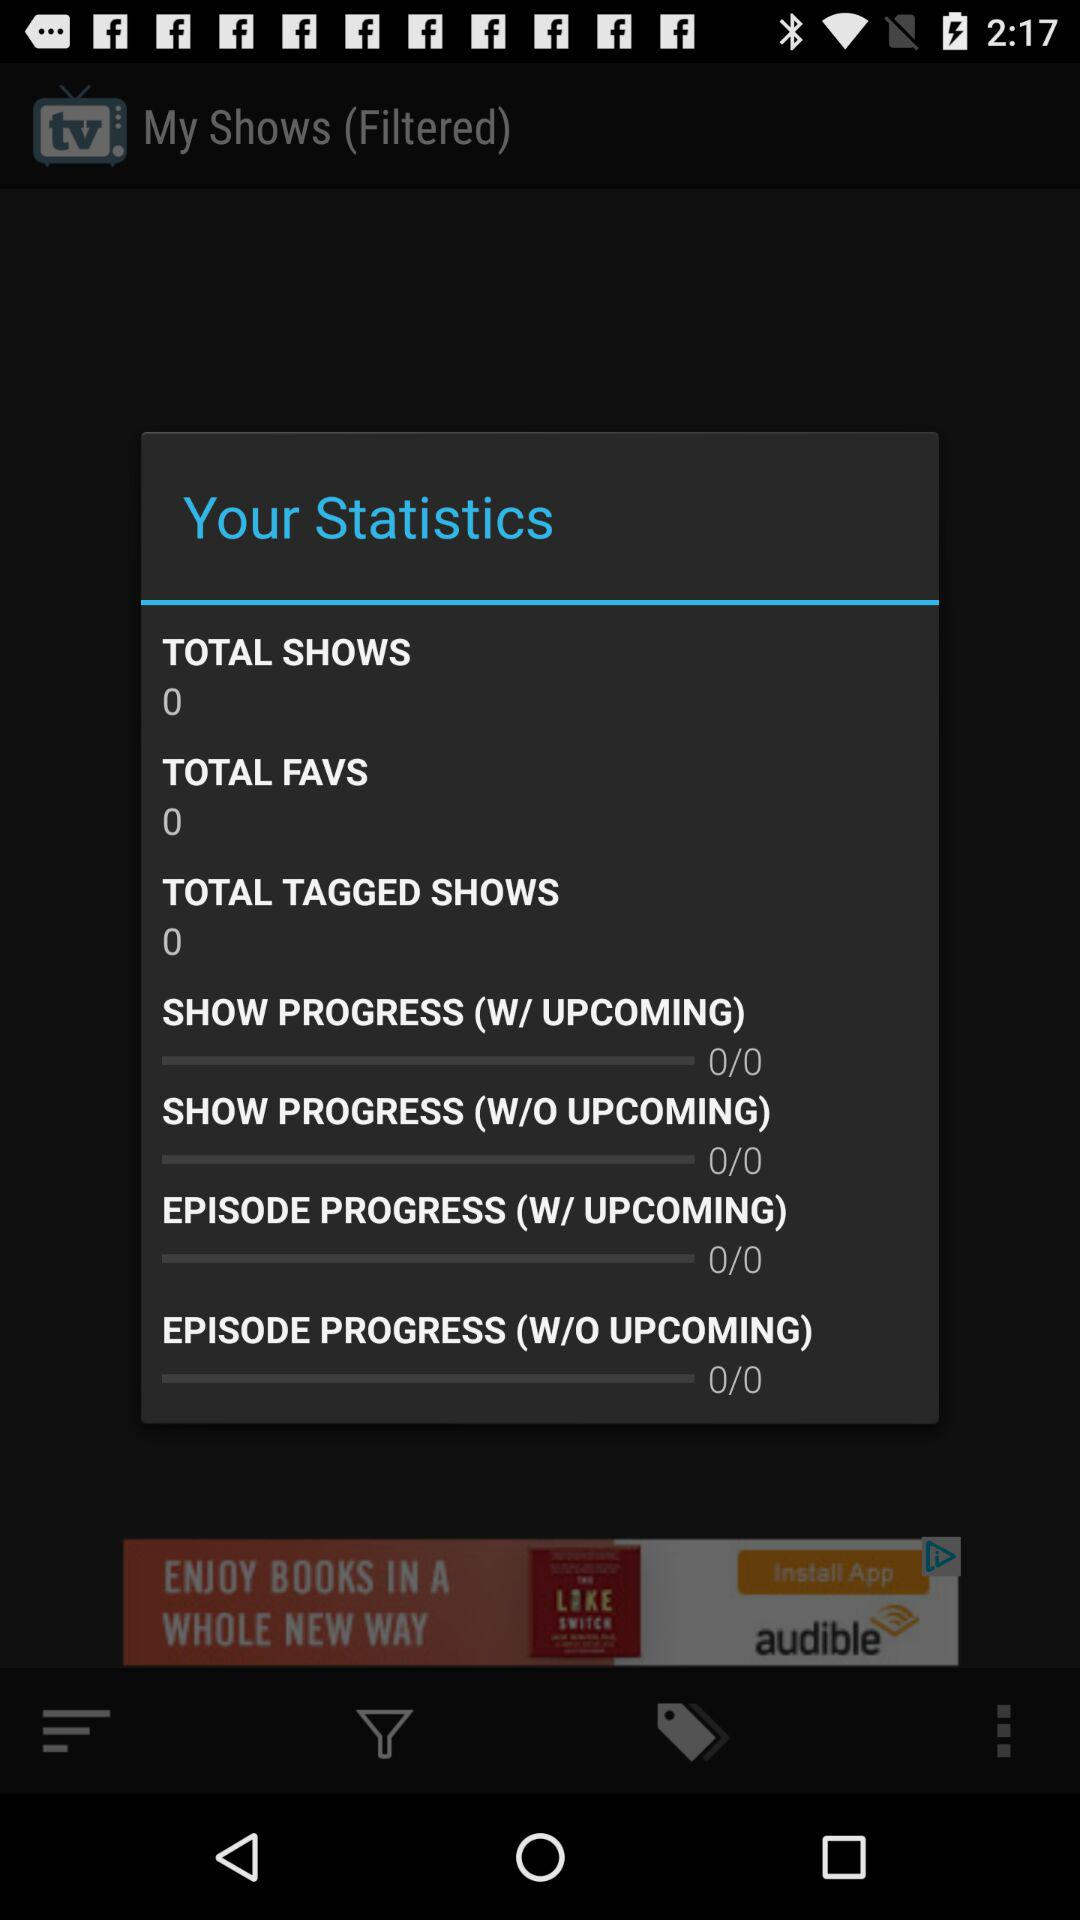How many shows have progressed?
When the provided information is insufficient, respond with <no answer>. <no answer> 